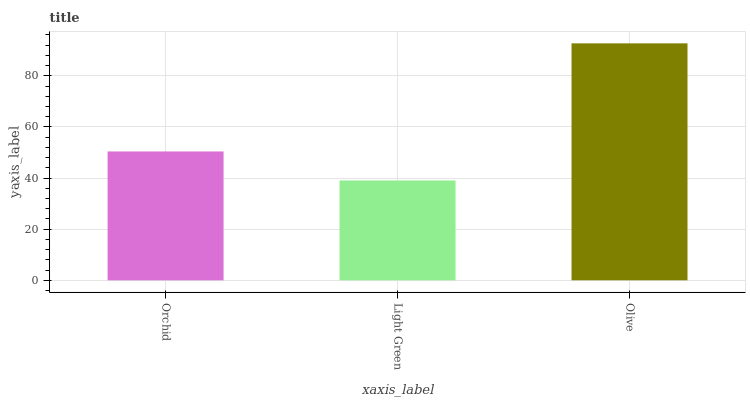Is Light Green the minimum?
Answer yes or no. Yes. Is Olive the maximum?
Answer yes or no. Yes. Is Olive the minimum?
Answer yes or no. No. Is Light Green the maximum?
Answer yes or no. No. Is Olive greater than Light Green?
Answer yes or no. Yes. Is Light Green less than Olive?
Answer yes or no. Yes. Is Light Green greater than Olive?
Answer yes or no. No. Is Olive less than Light Green?
Answer yes or no. No. Is Orchid the high median?
Answer yes or no. Yes. Is Orchid the low median?
Answer yes or no. Yes. Is Olive the high median?
Answer yes or no. No. Is Light Green the low median?
Answer yes or no. No. 